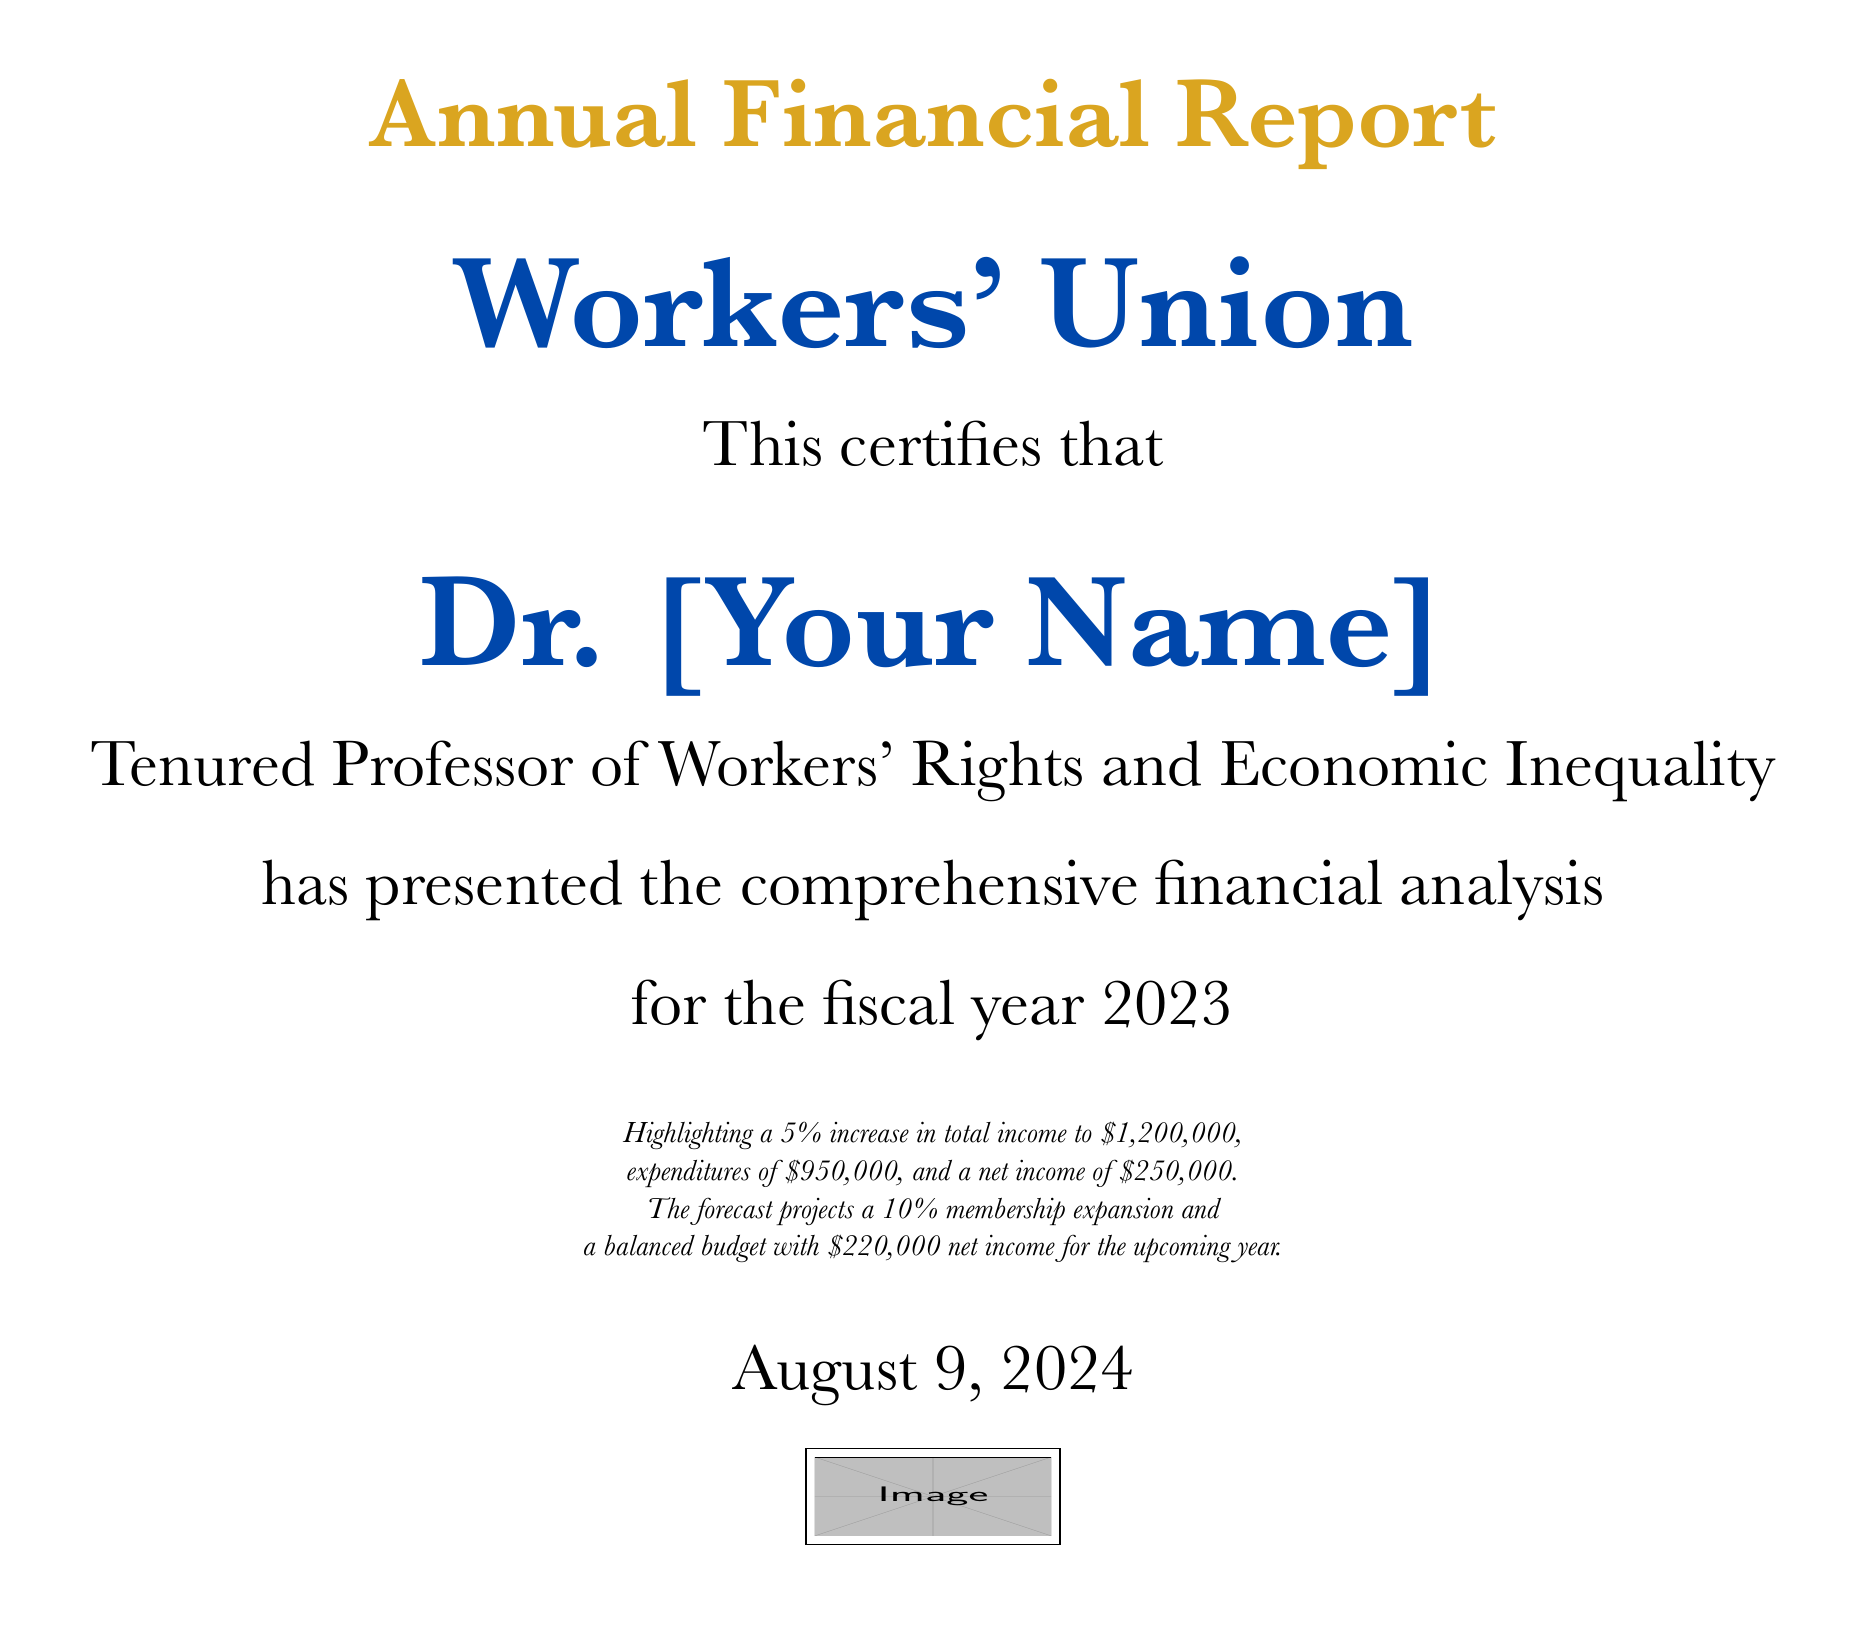What is the total income? The total income is stated in the document as $1,200,000.
Answer: $1,200,000 What is the net income for the fiscal year 2023? The net income for the fiscal year is calculated as total income minus expenditures, which is $250,000.
Answer: $250,000 Who presented the financial analysis? The diploma certifies that Dr. [Your Name] presented the comprehensive financial analysis.
Answer: Dr. [Your Name] What is the percentage increase in total income? The document mentions a 5% increase in total income.
Answer: 5% What is the forecast for membership expansion? The forecast indicates a 10% membership expansion.
Answer: 10% What is the projected net income for the upcoming year? The projected net income for the upcoming year is stated as $220,000.
Answer: $220,000 What title does Dr. [Your Name] hold? Dr. [Your Name] is referred to as a Tenured Professor of Workers' Rights and Economic Inequality.
Answer: Tenured Professor of Workers' Rights and Economic Inequality What is the total expenditure? The total expenditure for the fiscal year is provided as $950,000.
Answer: $950,000 What color is used for the union name? The color used for the union name is union blue.
Answer: union blue 